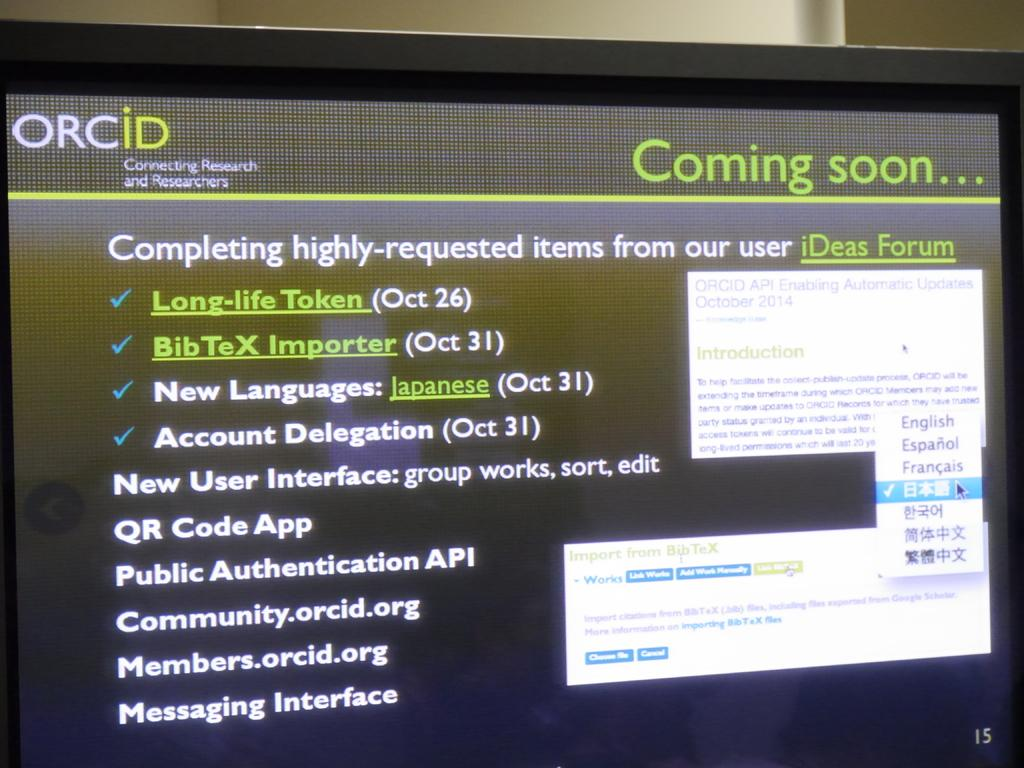<image>
Present a compact description of the photo's key features. A coming soon screen advertising a new user interface 